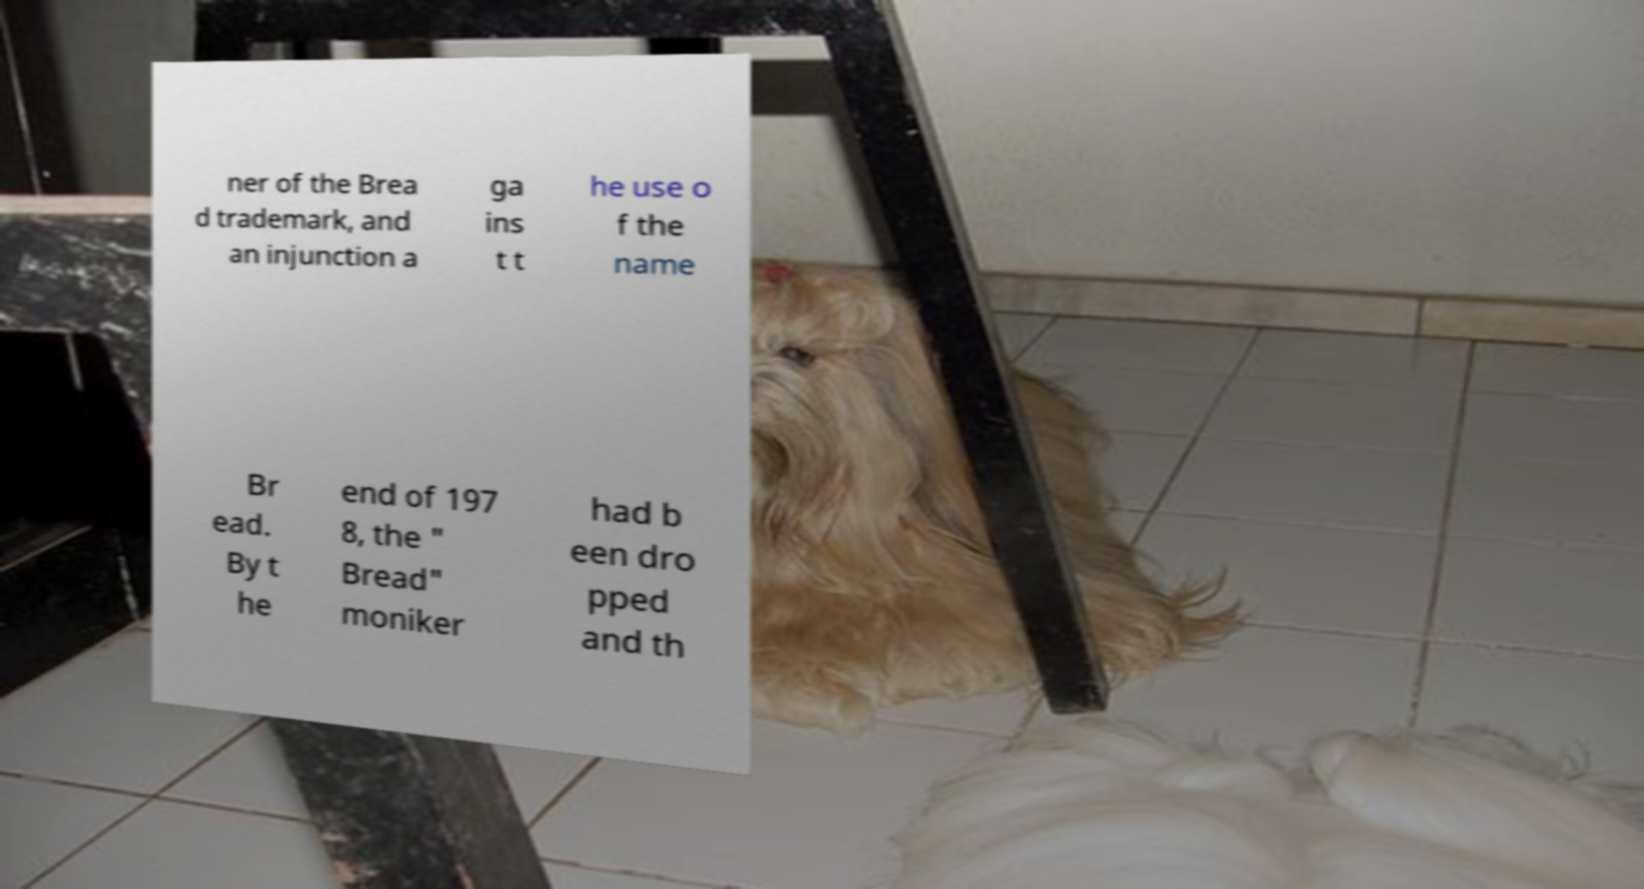What messages or text are displayed in this image? I need them in a readable, typed format. ner of the Brea d trademark, and an injunction a ga ins t t he use o f the name Br ead. By t he end of 197 8, the " Bread" moniker had b een dro pped and th 